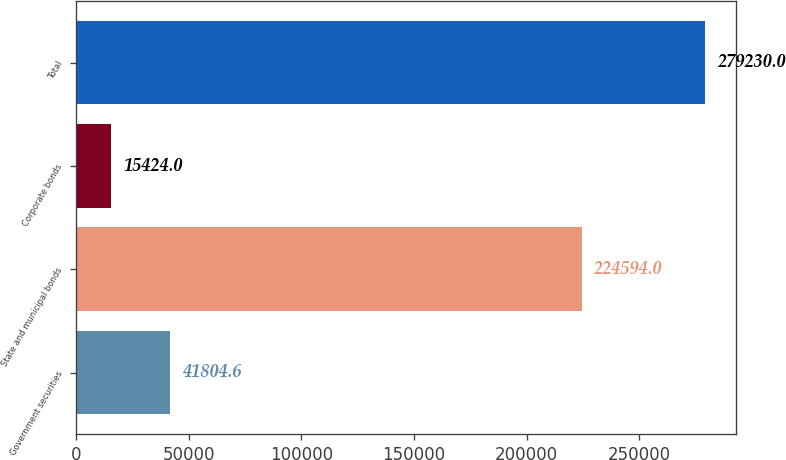Convert chart to OTSL. <chart><loc_0><loc_0><loc_500><loc_500><bar_chart><fcel>Government securities<fcel>State and municipal bonds<fcel>Corporate bonds<fcel>Total<nl><fcel>41804.6<fcel>224594<fcel>15424<fcel>279230<nl></chart> 